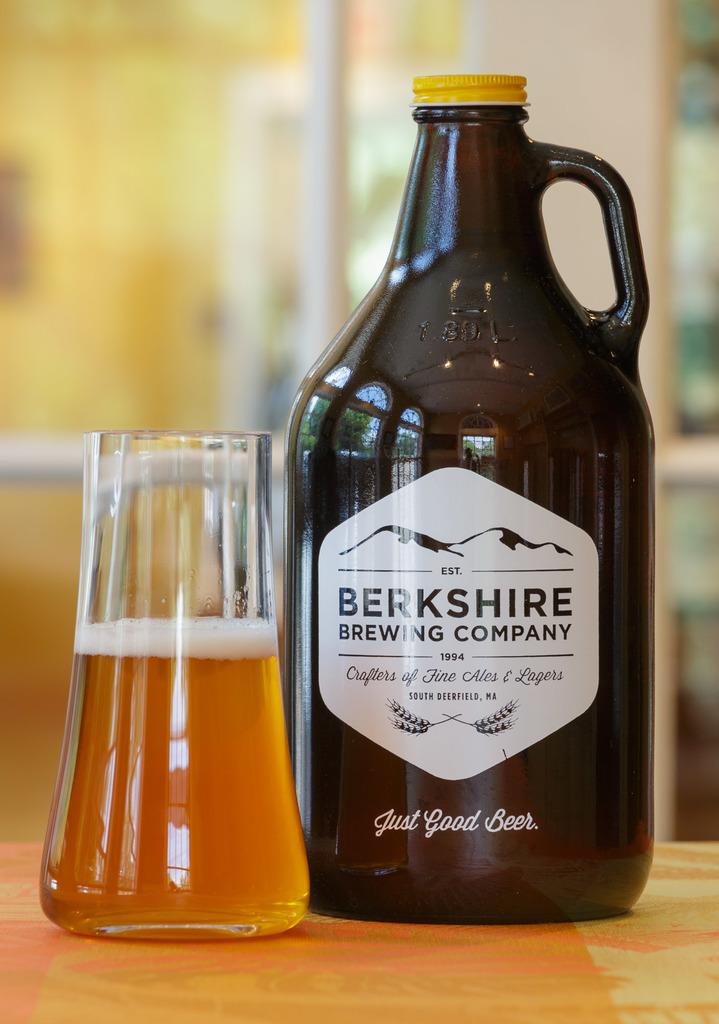What is the name of the brewing company?
Your response must be concise. Berkshire. What is the slogan of this brewing company?
Ensure brevity in your answer.  Just good beer. 